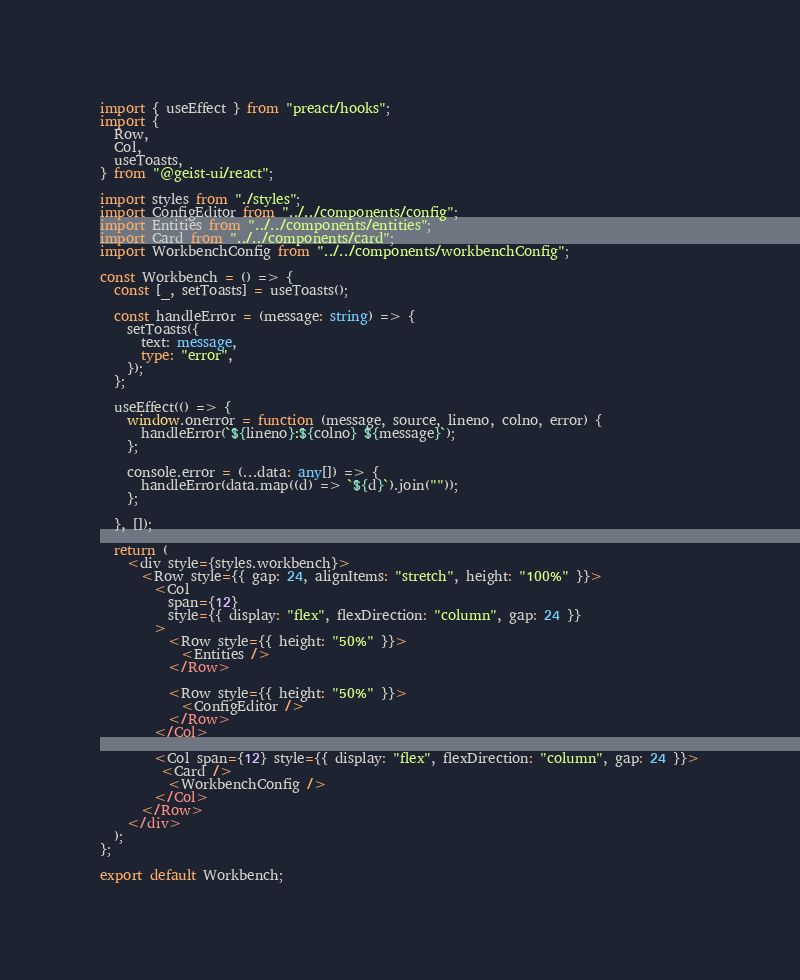Convert code to text. <code><loc_0><loc_0><loc_500><loc_500><_TypeScript_>import { useEffect } from "preact/hooks";
import {
  Row,
  Col,
  useToasts,
} from "@geist-ui/react";

import styles from "./styles";
import ConfigEditor from "../../components/config";
import Entities from "../../components/entities";
import Card from "../../components/card";
import WorkbenchConfig from "../../components/workbenchConfig";

const Workbench = () => {
  const [_, setToasts] = useToasts();

  const handleError = (message: string) => {
    setToasts({
      text: message,
      type: "error",
    });
  };

  useEffect(() => {
    window.onerror = function (message, source, lineno, colno, error) {
      handleError(`${lineno}:${colno} ${message}`);
    };

    console.error = (...data: any[]) => {
      handleError(data.map((d) => `${d}`).join(""));
    };

  }, []);

  return (
    <div style={styles.workbench}>
      <Row style={{ gap: 24, alignItems: "stretch", height: "100%" }}>
        <Col
          span={12}
          style={{ display: "flex", flexDirection: "column", gap: 24 }}
        >
          <Row style={{ height: "50%" }}>
            <Entities />
          </Row>

          <Row style={{ height: "50%" }}>
            <ConfigEditor />
          </Row>
        </Col>

        <Col span={12} style={{ display: "flex", flexDirection: "column", gap: 24 }}>
         <Card />
          <WorkbenchConfig />
        </Col>
      </Row>
    </div>
  );
};

export default Workbench;
</code> 